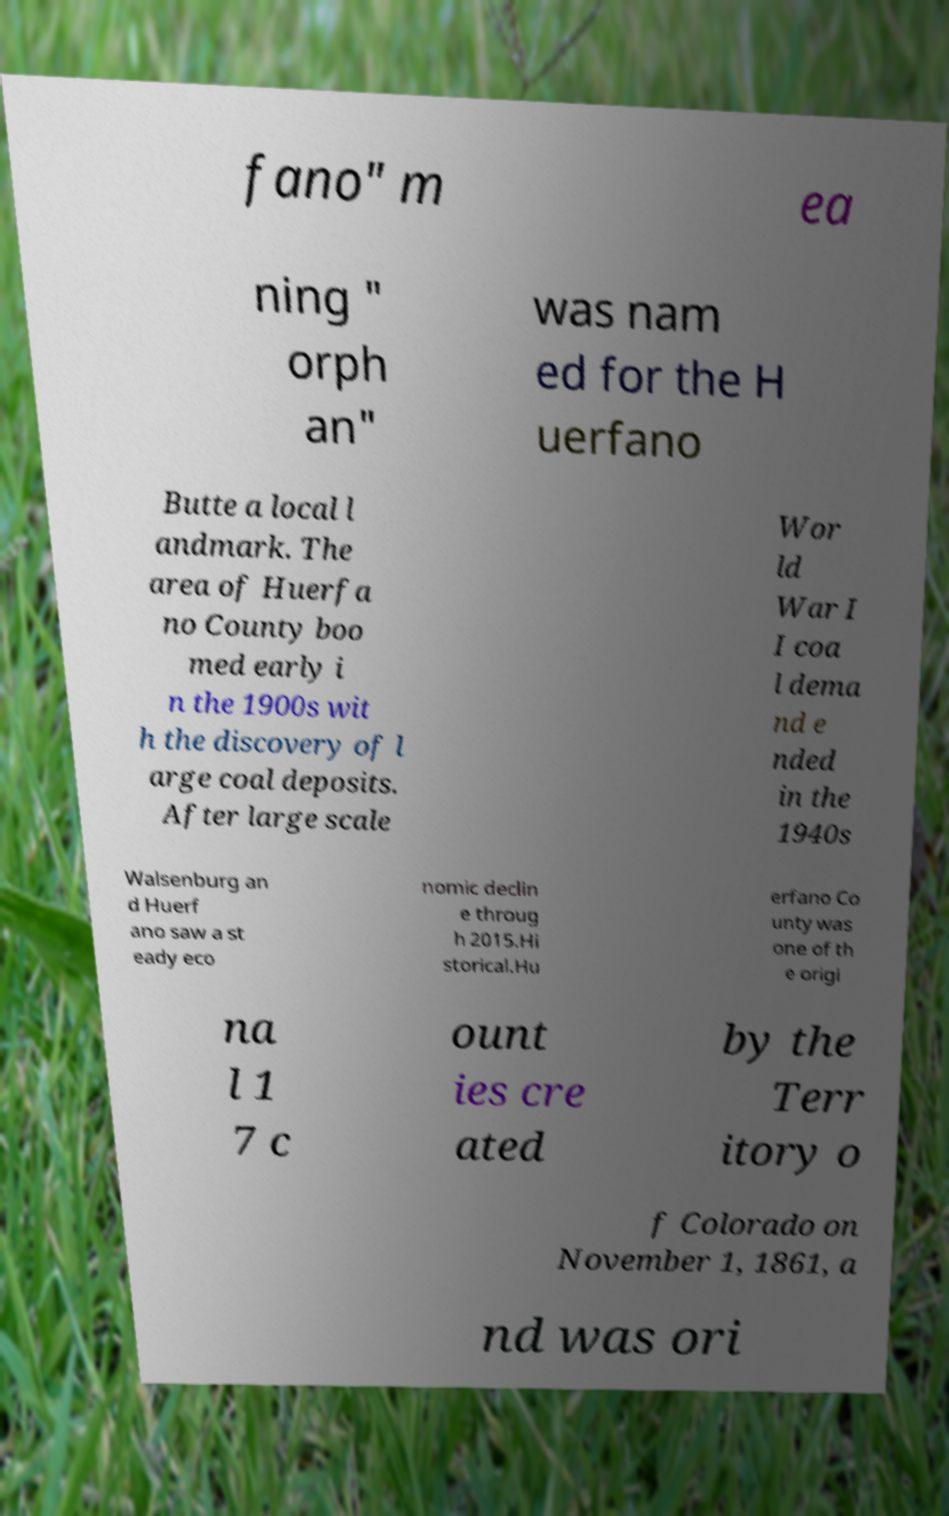Could you extract and type out the text from this image? fano" m ea ning " orph an" was nam ed for the H uerfano Butte a local l andmark. The area of Huerfa no County boo med early i n the 1900s wit h the discovery of l arge coal deposits. After large scale Wor ld War I I coa l dema nd e nded in the 1940s Walsenburg an d Huerf ano saw a st eady eco nomic declin e throug h 2015.Hi storical.Hu erfano Co unty was one of th e origi na l 1 7 c ount ies cre ated by the Terr itory o f Colorado on November 1, 1861, a nd was ori 